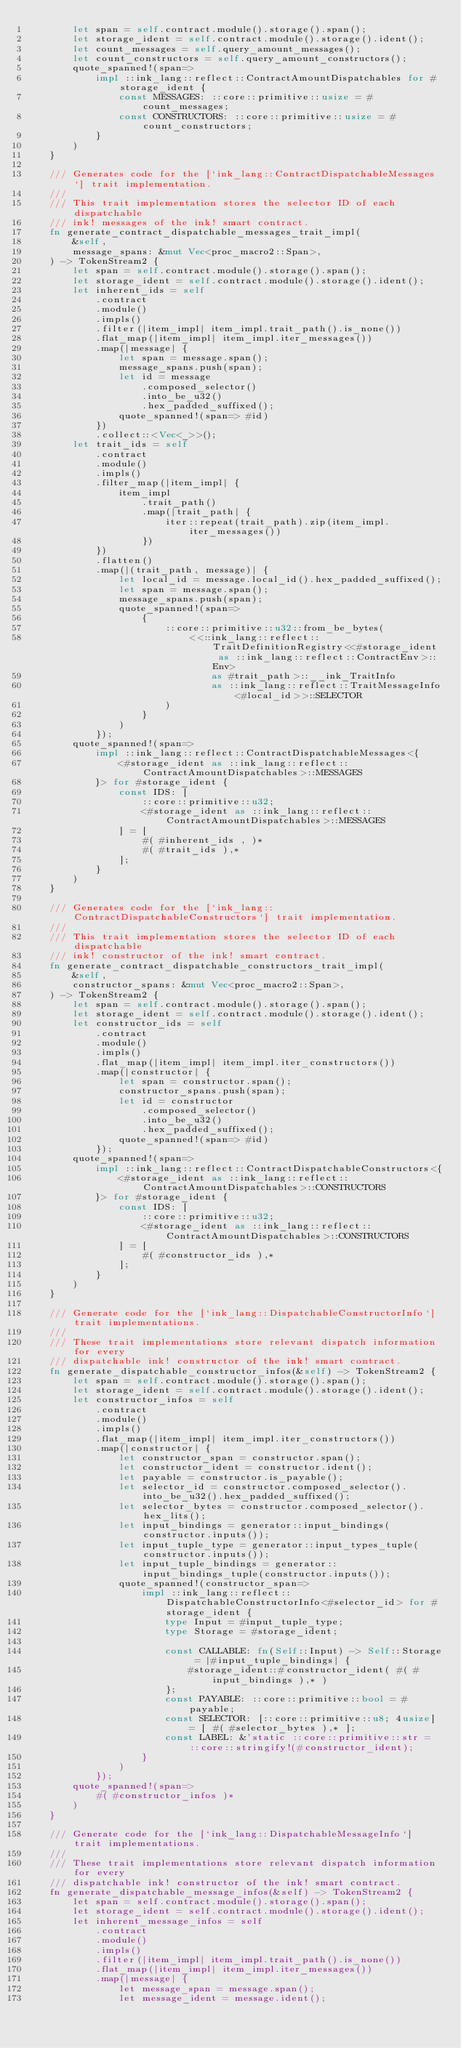<code> <loc_0><loc_0><loc_500><loc_500><_Rust_>        let span = self.contract.module().storage().span();
        let storage_ident = self.contract.module().storage().ident();
        let count_messages = self.query_amount_messages();
        let count_constructors = self.query_amount_constructors();
        quote_spanned!(span=>
            impl ::ink_lang::reflect::ContractAmountDispatchables for #storage_ident {
                const MESSAGES: ::core::primitive::usize = #count_messages;
                const CONSTRUCTORS: ::core::primitive::usize = #count_constructors;
            }
        )
    }

    /// Generates code for the [`ink_lang::ContractDispatchableMessages`] trait implementation.
    ///
    /// This trait implementation stores the selector ID of each dispatchable
    /// ink! messages of the ink! smart contract.
    fn generate_contract_dispatchable_messages_trait_impl(
        &self,
        message_spans: &mut Vec<proc_macro2::Span>,
    ) -> TokenStream2 {
        let span = self.contract.module().storage().span();
        let storage_ident = self.contract.module().storage().ident();
        let inherent_ids = self
            .contract
            .module()
            .impls()
            .filter(|item_impl| item_impl.trait_path().is_none())
            .flat_map(|item_impl| item_impl.iter_messages())
            .map(|message| {
                let span = message.span();
                message_spans.push(span);
                let id = message
                    .composed_selector()
                    .into_be_u32()
                    .hex_padded_suffixed();
                quote_spanned!(span=> #id)
            })
            .collect::<Vec<_>>();
        let trait_ids = self
            .contract
            .module()
            .impls()
            .filter_map(|item_impl| {
                item_impl
                    .trait_path()
                    .map(|trait_path| {
                        iter::repeat(trait_path).zip(item_impl.iter_messages())
                    })
            })
            .flatten()
            .map(|(trait_path, message)| {
                let local_id = message.local_id().hex_padded_suffixed();
                let span = message.span();
                message_spans.push(span);
                quote_spanned!(span=>
                    {
                        ::core::primitive::u32::from_be_bytes(
                            <<::ink_lang::reflect::TraitDefinitionRegistry<<#storage_ident as ::ink_lang::reflect::ContractEnv>::Env>
                                as #trait_path>::__ink_TraitInfo
                                as ::ink_lang::reflect::TraitMessageInfo<#local_id>>::SELECTOR
                        )
                    }
                )
            });
        quote_spanned!(span=>
            impl ::ink_lang::reflect::ContractDispatchableMessages<{
                <#storage_ident as ::ink_lang::reflect::ContractAmountDispatchables>::MESSAGES
            }> for #storage_ident {
                const IDS: [
                    ::core::primitive::u32;
                    <#storage_ident as ::ink_lang::reflect::ContractAmountDispatchables>::MESSAGES
                ] = [
                    #( #inherent_ids , )*
                    #( #trait_ids ),*
                ];
            }
        )
    }

    /// Generates code for the [`ink_lang::ContractDispatchableConstructors`] trait implementation.
    ///
    /// This trait implementation stores the selector ID of each dispatchable
    /// ink! constructor of the ink! smart contract.
    fn generate_contract_dispatchable_constructors_trait_impl(
        &self,
        constructor_spans: &mut Vec<proc_macro2::Span>,
    ) -> TokenStream2 {
        let span = self.contract.module().storage().span();
        let storage_ident = self.contract.module().storage().ident();
        let constructor_ids = self
            .contract
            .module()
            .impls()
            .flat_map(|item_impl| item_impl.iter_constructors())
            .map(|constructor| {
                let span = constructor.span();
                constructor_spans.push(span);
                let id = constructor
                    .composed_selector()
                    .into_be_u32()
                    .hex_padded_suffixed();
                quote_spanned!(span=> #id)
            });
        quote_spanned!(span=>
            impl ::ink_lang::reflect::ContractDispatchableConstructors<{
                <#storage_ident as ::ink_lang::reflect::ContractAmountDispatchables>::CONSTRUCTORS
            }> for #storage_ident {
                const IDS: [
                    ::core::primitive::u32;
                    <#storage_ident as ::ink_lang::reflect::ContractAmountDispatchables>::CONSTRUCTORS
                ] = [
                    #( #constructor_ids ),*
                ];
            }
        )
    }

    /// Generate code for the [`ink_lang::DispatchableConstructorInfo`] trait implementations.
    ///
    /// These trait implementations store relevant dispatch information for every
    /// dispatchable ink! constructor of the ink! smart contract.
    fn generate_dispatchable_constructor_infos(&self) -> TokenStream2 {
        let span = self.contract.module().storage().span();
        let storage_ident = self.contract.module().storage().ident();
        let constructor_infos = self
            .contract
            .module()
            .impls()
            .flat_map(|item_impl| item_impl.iter_constructors())
            .map(|constructor| {
                let constructor_span = constructor.span();
                let constructor_ident = constructor.ident();
                let payable = constructor.is_payable();
                let selector_id = constructor.composed_selector().into_be_u32().hex_padded_suffixed();
                let selector_bytes = constructor.composed_selector().hex_lits();
                let input_bindings = generator::input_bindings(constructor.inputs());
                let input_tuple_type = generator::input_types_tuple(constructor.inputs());
                let input_tuple_bindings = generator::input_bindings_tuple(constructor.inputs());
                quote_spanned!(constructor_span=>
                    impl ::ink_lang::reflect::DispatchableConstructorInfo<#selector_id> for #storage_ident {
                        type Input = #input_tuple_type;
                        type Storage = #storage_ident;

                        const CALLABLE: fn(Self::Input) -> Self::Storage = |#input_tuple_bindings| {
                            #storage_ident::#constructor_ident( #( #input_bindings ),* )
                        };
                        const PAYABLE: ::core::primitive::bool = #payable;
                        const SELECTOR: [::core::primitive::u8; 4usize] = [ #( #selector_bytes ),* ];
                        const LABEL: &'static ::core::primitive::str = ::core::stringify!(#constructor_ident);
                    }
                )
            });
        quote_spanned!(span=>
            #( #constructor_infos )*
        )
    }

    /// Generate code for the [`ink_lang::DispatchableMessageInfo`] trait implementations.
    ///
    /// These trait implementations store relevant dispatch information for every
    /// dispatchable ink! constructor of the ink! smart contract.
    fn generate_dispatchable_message_infos(&self) -> TokenStream2 {
        let span = self.contract.module().storage().span();
        let storage_ident = self.contract.module().storage().ident();
        let inherent_message_infos = self
            .contract
            .module()
            .impls()
            .filter(|item_impl| item_impl.trait_path().is_none())
            .flat_map(|item_impl| item_impl.iter_messages())
            .map(|message| {
                let message_span = message.span();
                let message_ident = message.ident();</code> 